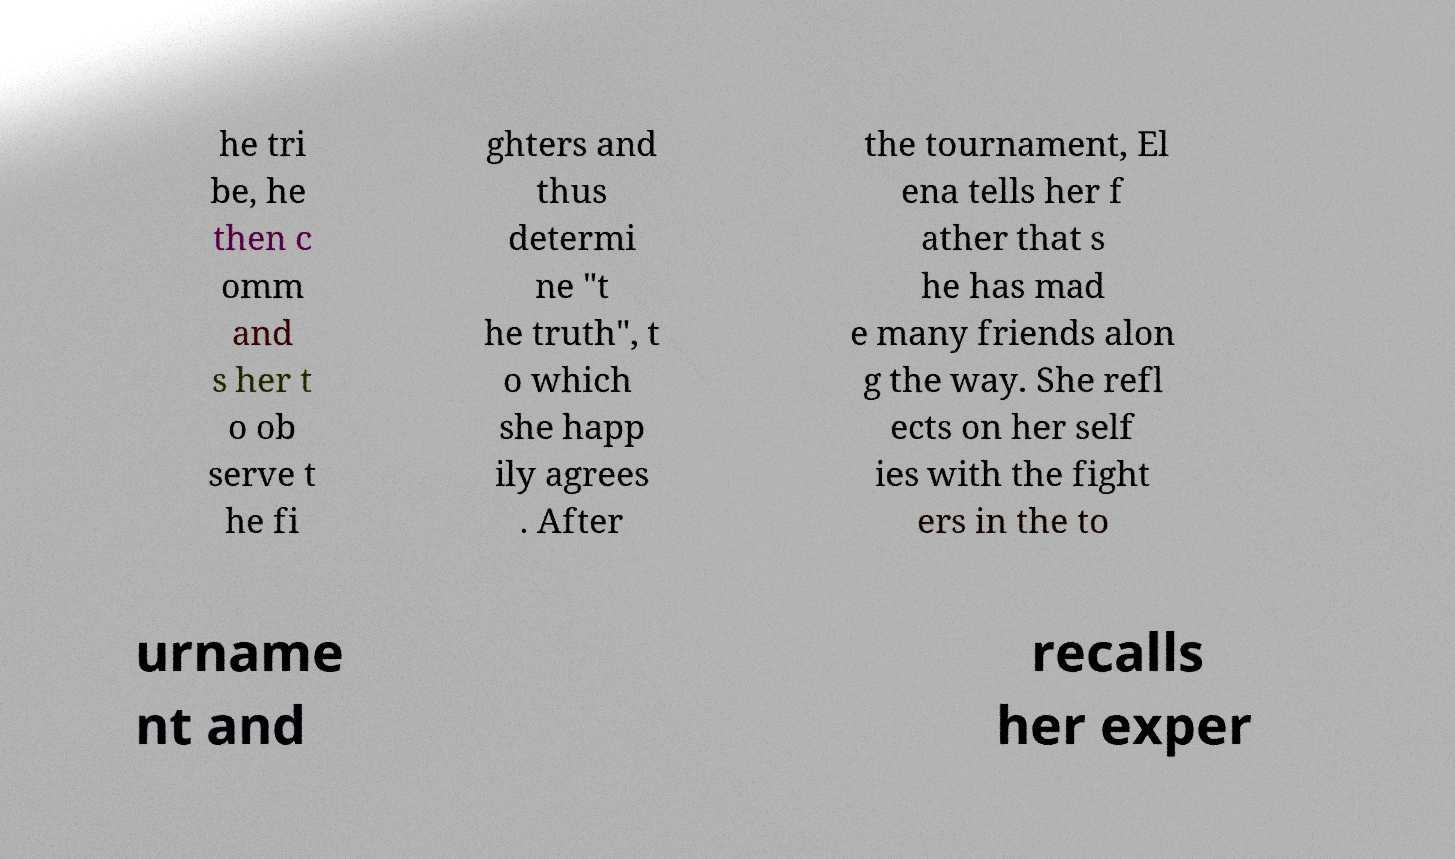Please identify and transcribe the text found in this image. he tri be, he then c omm and s her t o ob serve t he fi ghters and thus determi ne "t he truth", t o which she happ ily agrees . After the tournament, El ena tells her f ather that s he has mad e many friends alon g the way. She refl ects on her self ies with the fight ers in the to urname nt and recalls her exper 